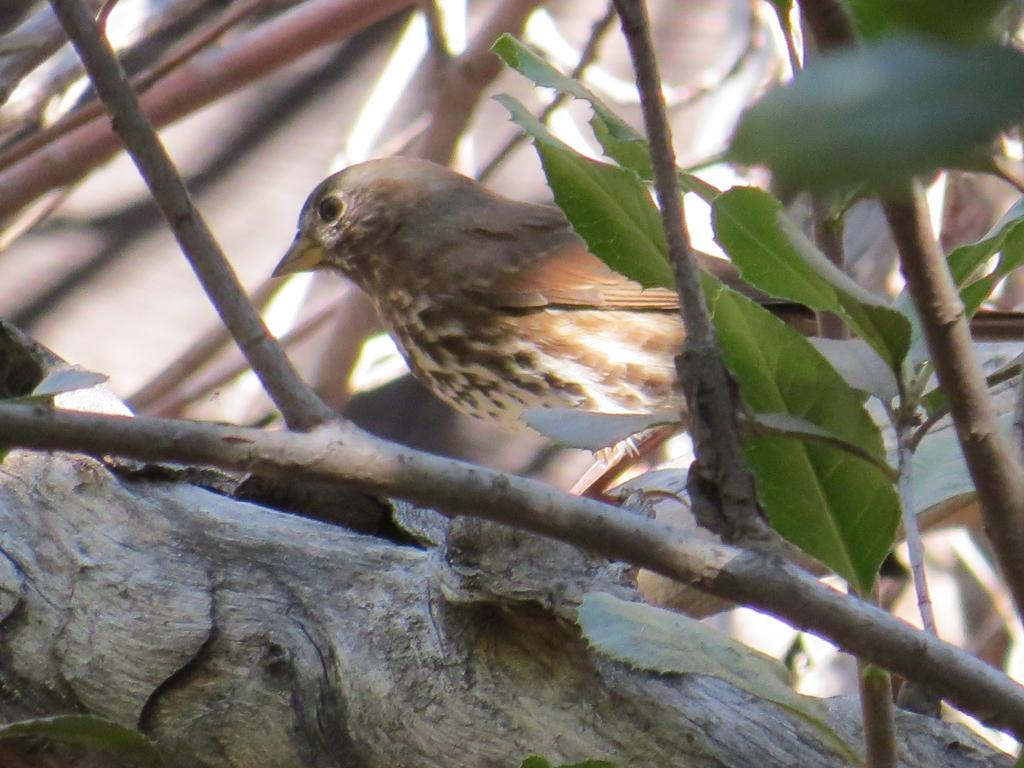What type of animal is present in the image? There is a bird in the image. What is the bird doing in the image? The bird is standing in the image. What can be seen in the background of the image? There are branches and leaves in the image. What song is the bird singing in the image? There is no indication in the image that the bird is singing a song. What position does the bird hold on the team in the image? There is no team present in the image, and therefore no position for the bird to hold. 